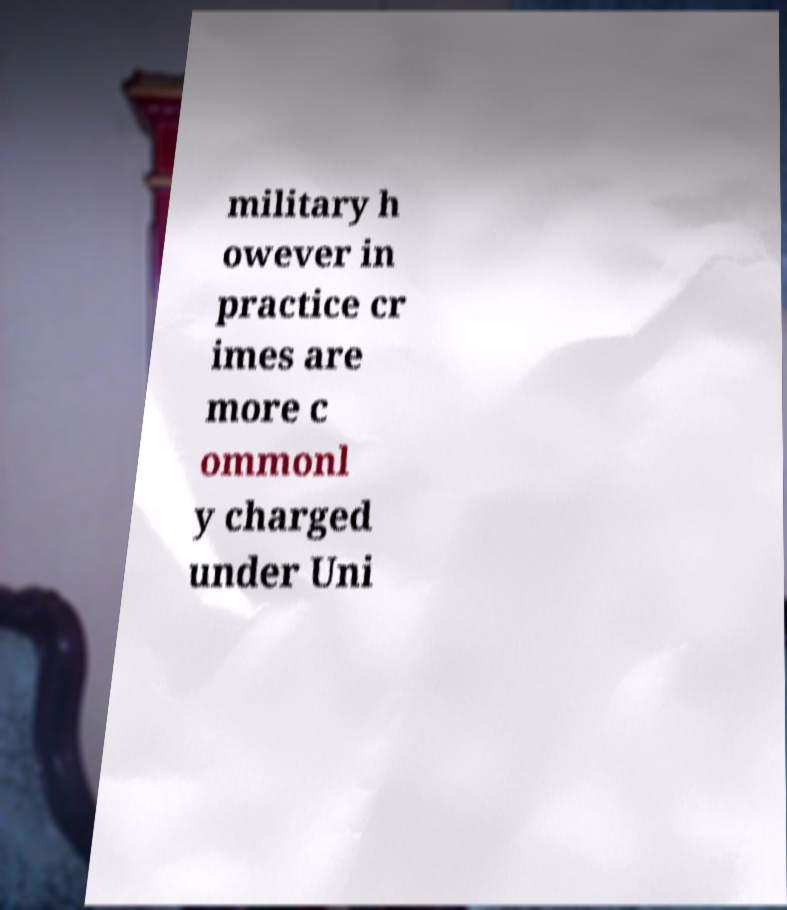For documentation purposes, I need the text within this image transcribed. Could you provide that? military h owever in practice cr imes are more c ommonl y charged under Uni 